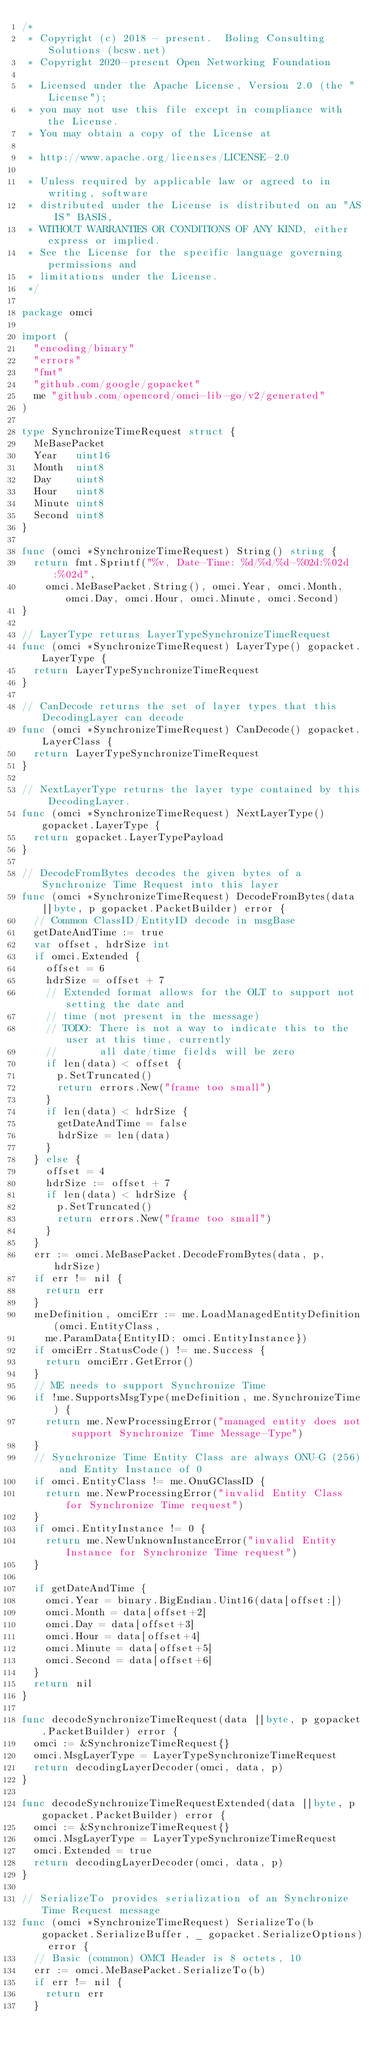Convert code to text. <code><loc_0><loc_0><loc_500><loc_500><_Go_>/*
 * Copyright (c) 2018 - present.  Boling Consulting Solutions (bcsw.net)
 * Copyright 2020-present Open Networking Foundation

 * Licensed under the Apache License, Version 2.0 (the "License");
 * you may not use this file except in compliance with the License.
 * You may obtain a copy of the License at

 * http://www.apache.org/licenses/LICENSE-2.0

 * Unless required by applicable law or agreed to in writing, software
 * distributed under the License is distributed on an "AS IS" BASIS,
 * WITHOUT WARRANTIES OR CONDITIONS OF ANY KIND, either express or implied.
 * See the License for the specific language governing permissions and
 * limitations under the License.
 */

package omci

import (
	"encoding/binary"
	"errors"
	"fmt"
	"github.com/google/gopacket"
	me "github.com/opencord/omci-lib-go/v2/generated"
)

type SynchronizeTimeRequest struct {
	MeBasePacket
	Year   uint16
	Month  uint8
	Day    uint8
	Hour   uint8
	Minute uint8
	Second uint8
}

func (omci *SynchronizeTimeRequest) String() string {
	return fmt.Sprintf("%v, Date-Time: %d/%d/%d-%02d:%02d:%02d",
		omci.MeBasePacket.String(), omci.Year, omci.Month, omci.Day, omci.Hour, omci.Minute, omci.Second)
}

// LayerType returns LayerTypeSynchronizeTimeRequest
func (omci *SynchronizeTimeRequest) LayerType() gopacket.LayerType {
	return LayerTypeSynchronizeTimeRequest
}

// CanDecode returns the set of layer types that this DecodingLayer can decode
func (omci *SynchronizeTimeRequest) CanDecode() gopacket.LayerClass {
	return LayerTypeSynchronizeTimeRequest
}

// NextLayerType returns the layer type contained by this DecodingLayer.
func (omci *SynchronizeTimeRequest) NextLayerType() gopacket.LayerType {
	return gopacket.LayerTypePayload
}

// DecodeFromBytes decodes the given bytes of a Synchronize Time Request into this layer
func (omci *SynchronizeTimeRequest) DecodeFromBytes(data []byte, p gopacket.PacketBuilder) error {
	// Common ClassID/EntityID decode in msgBase
	getDateAndTime := true
	var offset, hdrSize int
	if omci.Extended {
		offset = 6
		hdrSize = offset + 7
		// Extended format allows for the OLT to support not setting the date and
		// time (not present in the message)
		// TODO: There is not a way to indicate this to the user at this time, currently
		//       all date/time fields will be zero
		if len(data) < offset {
			p.SetTruncated()
			return errors.New("frame too small")
		}
		if len(data) < hdrSize {
			getDateAndTime = false
			hdrSize = len(data)
		}
	} else {
		offset = 4
		hdrSize := offset + 7
		if len(data) < hdrSize {
			p.SetTruncated()
			return errors.New("frame too small")
		}
	}
	err := omci.MeBasePacket.DecodeFromBytes(data, p, hdrSize)
	if err != nil {
		return err
	}
	meDefinition, omciErr := me.LoadManagedEntityDefinition(omci.EntityClass,
		me.ParamData{EntityID: omci.EntityInstance})
	if omciErr.StatusCode() != me.Success {
		return omciErr.GetError()
	}
	// ME needs to support Synchronize Time
	if !me.SupportsMsgType(meDefinition, me.SynchronizeTime) {
		return me.NewProcessingError("managed entity does not support Synchronize Time Message-Type")
	}
	// Synchronize Time Entity Class are always ONU-G (256) and Entity Instance of 0
	if omci.EntityClass != me.OnuGClassID {
		return me.NewProcessingError("invalid Entity Class for Synchronize Time request")
	}
	if omci.EntityInstance != 0 {
		return me.NewUnknownInstanceError("invalid Entity Instance for Synchronize Time request")
	}

	if getDateAndTime {
		omci.Year = binary.BigEndian.Uint16(data[offset:])
		omci.Month = data[offset+2]
		omci.Day = data[offset+3]
		omci.Hour = data[offset+4]
		omci.Minute = data[offset+5]
		omci.Second = data[offset+6]
	}
	return nil
}

func decodeSynchronizeTimeRequest(data []byte, p gopacket.PacketBuilder) error {
	omci := &SynchronizeTimeRequest{}
	omci.MsgLayerType = LayerTypeSynchronizeTimeRequest
	return decodingLayerDecoder(omci, data, p)
}

func decodeSynchronizeTimeRequestExtended(data []byte, p gopacket.PacketBuilder) error {
	omci := &SynchronizeTimeRequest{}
	omci.MsgLayerType = LayerTypeSynchronizeTimeRequest
	omci.Extended = true
	return decodingLayerDecoder(omci, data, p)
}

// SerializeTo provides serialization of an Synchronize Time Request message
func (omci *SynchronizeTimeRequest) SerializeTo(b gopacket.SerializeBuffer, _ gopacket.SerializeOptions) error {
	// Basic (common) OMCI Header is 8 octets, 10
	err := omci.MeBasePacket.SerializeTo(b)
	if err != nil {
		return err
	}</code> 